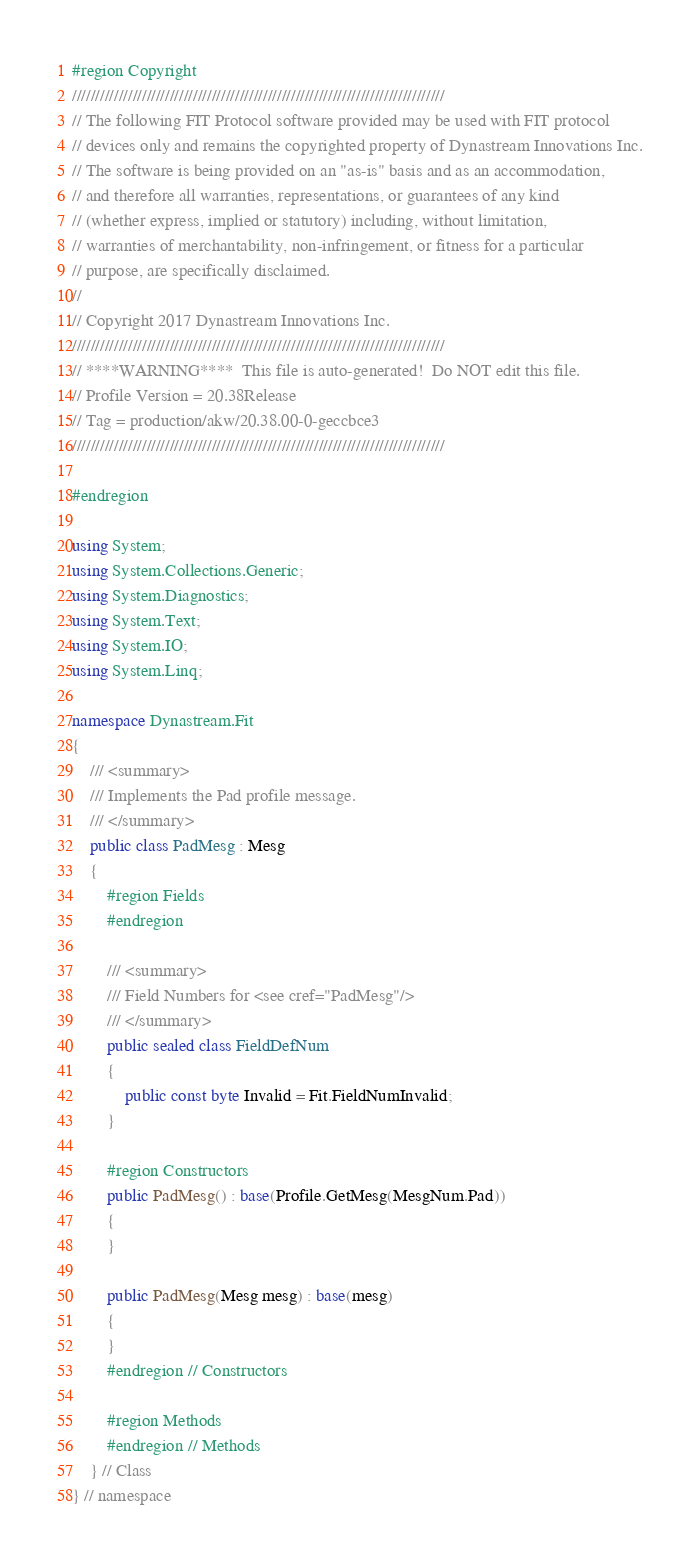Convert code to text. <code><loc_0><loc_0><loc_500><loc_500><_C#_>#region Copyright
////////////////////////////////////////////////////////////////////////////////
// The following FIT Protocol software provided may be used with FIT protocol
// devices only and remains the copyrighted property of Dynastream Innovations Inc.
// The software is being provided on an "as-is" basis and as an accommodation,
// and therefore all warranties, representations, or guarantees of any kind
// (whether express, implied or statutory) including, without limitation,
// warranties of merchantability, non-infringement, or fitness for a particular
// purpose, are specifically disclaimed.
//
// Copyright 2017 Dynastream Innovations Inc.
////////////////////////////////////////////////////////////////////////////////
// ****WARNING****  This file is auto-generated!  Do NOT edit this file.
// Profile Version = 20.38Release
// Tag = production/akw/20.38.00-0-geccbce3
////////////////////////////////////////////////////////////////////////////////

#endregion

using System;
using System.Collections.Generic;
using System.Diagnostics;
using System.Text;
using System.IO;
using System.Linq;

namespace Dynastream.Fit
{
    /// <summary>
    /// Implements the Pad profile message.
    /// </summary>
    public class PadMesg : Mesg
    {
        #region Fields
        #endregion

        /// <summary>
        /// Field Numbers for <see cref="PadMesg"/>
        /// </summary>
        public sealed class FieldDefNum
        {
            public const byte Invalid = Fit.FieldNumInvalid;
        }

        #region Constructors
        public PadMesg() : base(Profile.GetMesg(MesgNum.Pad))
        {
        }

        public PadMesg(Mesg mesg) : base(mesg)
        {
        }
        #endregion // Constructors

        #region Methods
        #endregion // Methods
    } // Class
} // namespace
</code> 